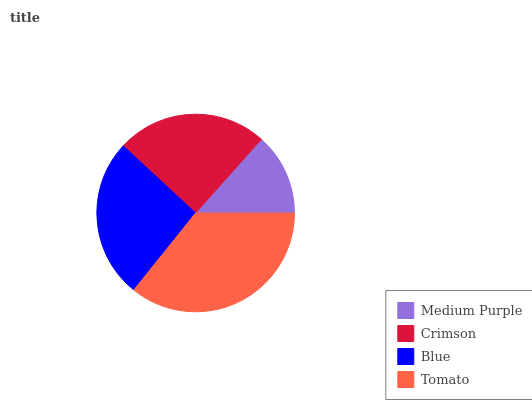Is Medium Purple the minimum?
Answer yes or no. Yes. Is Tomato the maximum?
Answer yes or no. Yes. Is Crimson the minimum?
Answer yes or no. No. Is Crimson the maximum?
Answer yes or no. No. Is Crimson greater than Medium Purple?
Answer yes or no. Yes. Is Medium Purple less than Crimson?
Answer yes or no. Yes. Is Medium Purple greater than Crimson?
Answer yes or no. No. Is Crimson less than Medium Purple?
Answer yes or no. No. Is Blue the high median?
Answer yes or no. Yes. Is Crimson the low median?
Answer yes or no. Yes. Is Tomato the high median?
Answer yes or no. No. Is Medium Purple the low median?
Answer yes or no. No. 